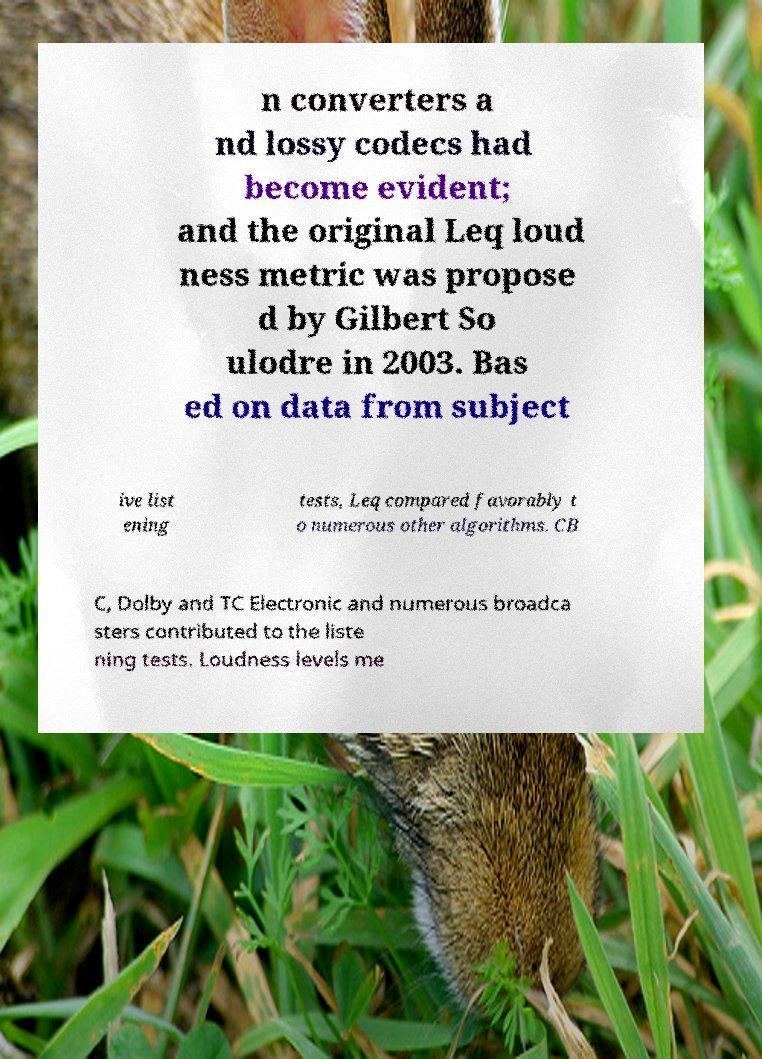I need the written content from this picture converted into text. Can you do that? n converters a nd lossy codecs had become evident; and the original Leq loud ness metric was propose d by Gilbert So ulodre in 2003. Bas ed on data from subject ive list ening tests, Leq compared favorably t o numerous other algorithms. CB C, Dolby and TC Electronic and numerous broadca sters contributed to the liste ning tests. Loudness levels me 